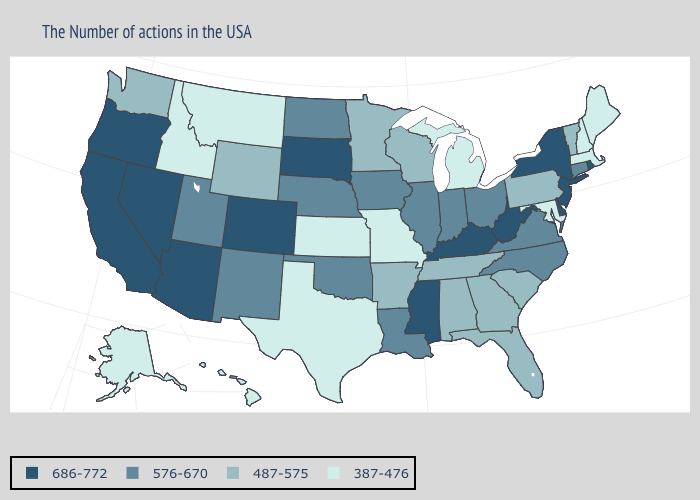Name the states that have a value in the range 686-772?
Answer briefly. Rhode Island, New York, New Jersey, Delaware, West Virginia, Kentucky, Mississippi, South Dakota, Colorado, Arizona, Nevada, California, Oregon. Name the states that have a value in the range 387-476?
Write a very short answer. Maine, Massachusetts, New Hampshire, Maryland, Michigan, Missouri, Kansas, Texas, Montana, Idaho, Alaska, Hawaii. Name the states that have a value in the range 487-575?
Give a very brief answer. Vermont, Pennsylvania, South Carolina, Florida, Georgia, Alabama, Tennessee, Wisconsin, Arkansas, Minnesota, Wyoming, Washington. Name the states that have a value in the range 387-476?
Short answer required. Maine, Massachusetts, New Hampshire, Maryland, Michigan, Missouri, Kansas, Texas, Montana, Idaho, Alaska, Hawaii. Does the map have missing data?
Keep it brief. No. Among the states that border Louisiana , does Arkansas have the lowest value?
Concise answer only. No. What is the highest value in the South ?
Write a very short answer. 686-772. What is the value of South Dakota?
Keep it brief. 686-772. Is the legend a continuous bar?
Answer briefly. No. Which states have the highest value in the USA?
Short answer required. Rhode Island, New York, New Jersey, Delaware, West Virginia, Kentucky, Mississippi, South Dakota, Colorado, Arizona, Nevada, California, Oregon. Name the states that have a value in the range 487-575?
Quick response, please. Vermont, Pennsylvania, South Carolina, Florida, Georgia, Alabama, Tennessee, Wisconsin, Arkansas, Minnesota, Wyoming, Washington. Does Michigan have a lower value than Georgia?
Keep it brief. Yes. What is the value of Utah?
Keep it brief. 576-670. Does the first symbol in the legend represent the smallest category?
Concise answer only. No. 